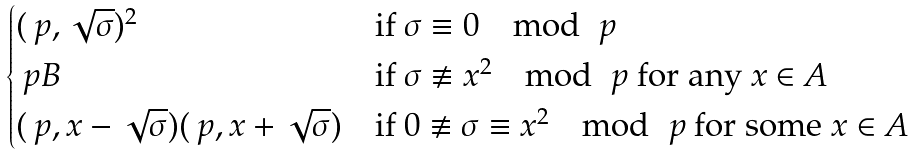Convert formula to latex. <formula><loc_0><loc_0><loc_500><loc_500>\begin{cases} ( \ p , \sqrt { \sigma } ) ^ { 2 } & \text {if } \sigma \equiv 0 \mod \ p \\ \ p B & \text {if } \sigma \not \equiv x ^ { 2 } \mod \ p \text { for any } x \in A \\ ( \ p , x - \sqrt { \sigma } ) ( \ p , x + \sqrt { \sigma } ) & \text {if } 0 \not \equiv \sigma \equiv x ^ { 2 } \mod \ p \text { for some } x \in A \end{cases}</formula> 